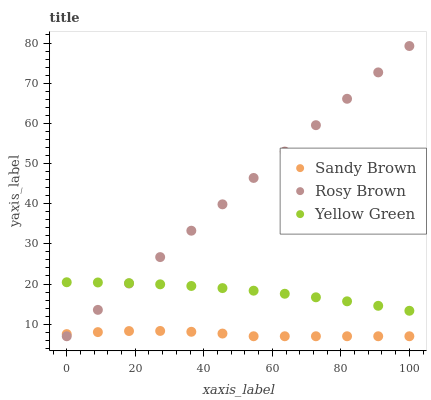Does Sandy Brown have the minimum area under the curve?
Answer yes or no. Yes. Does Rosy Brown have the maximum area under the curve?
Answer yes or no. Yes. Does Yellow Green have the minimum area under the curve?
Answer yes or no. No. Does Yellow Green have the maximum area under the curve?
Answer yes or no. No. Is Rosy Brown the smoothest?
Answer yes or no. Yes. Is Sandy Brown the roughest?
Answer yes or no. Yes. Is Yellow Green the smoothest?
Answer yes or no. No. Is Yellow Green the roughest?
Answer yes or no. No. Does Rosy Brown have the lowest value?
Answer yes or no. Yes. Does Yellow Green have the lowest value?
Answer yes or no. No. Does Rosy Brown have the highest value?
Answer yes or no. Yes. Does Yellow Green have the highest value?
Answer yes or no. No. Is Sandy Brown less than Yellow Green?
Answer yes or no. Yes. Is Yellow Green greater than Sandy Brown?
Answer yes or no. Yes. Does Sandy Brown intersect Rosy Brown?
Answer yes or no. Yes. Is Sandy Brown less than Rosy Brown?
Answer yes or no. No. Is Sandy Brown greater than Rosy Brown?
Answer yes or no. No. Does Sandy Brown intersect Yellow Green?
Answer yes or no. No. 